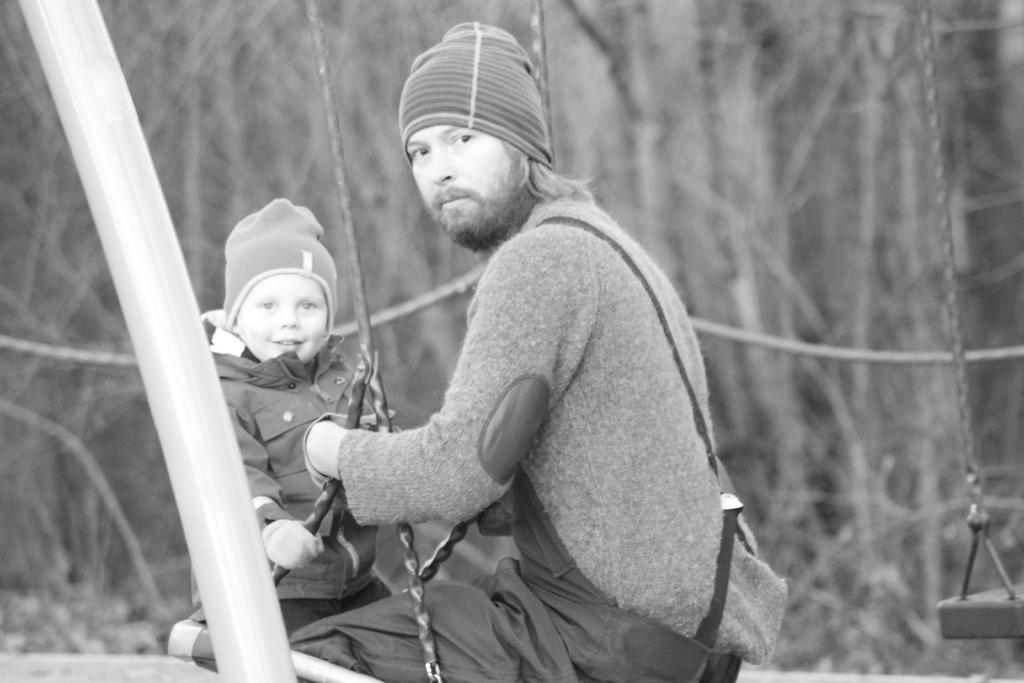Who is present in the image? There is a man and a kid in the image. What are the man and the kid doing in the image? The man and the kid are sitting on a swing. What can be seen on the left side of the image? There is a rod on the left side of the image. What is on the right side of the image? There is a swing on the right side of the image. What is visible in the background of the image? There are trees in the background of the image. How many pizzas are being served to the army in the image? There are no pizzas or army members present in the image. What type of hook is attached to the swing in the image? There is no hook visible in the image; the swing is connected to a rod. 